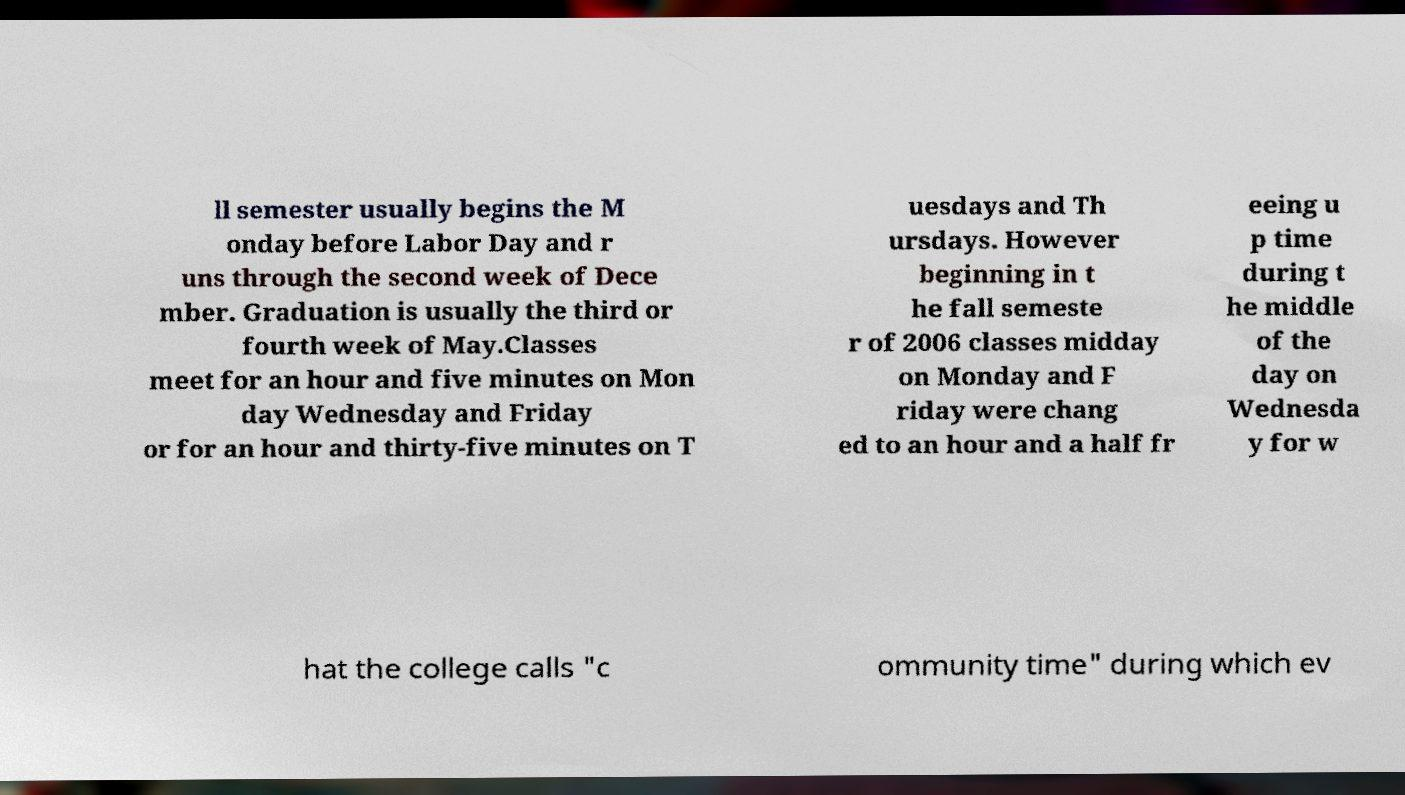Could you extract and type out the text from this image? ll semester usually begins the M onday before Labor Day and r uns through the second week of Dece mber. Graduation is usually the third or fourth week of May.Classes meet for an hour and five minutes on Mon day Wednesday and Friday or for an hour and thirty-five minutes on T uesdays and Th ursdays. However beginning in t he fall semeste r of 2006 classes midday on Monday and F riday were chang ed to an hour and a half fr eeing u p time during t he middle of the day on Wednesda y for w hat the college calls "c ommunity time" during which ev 